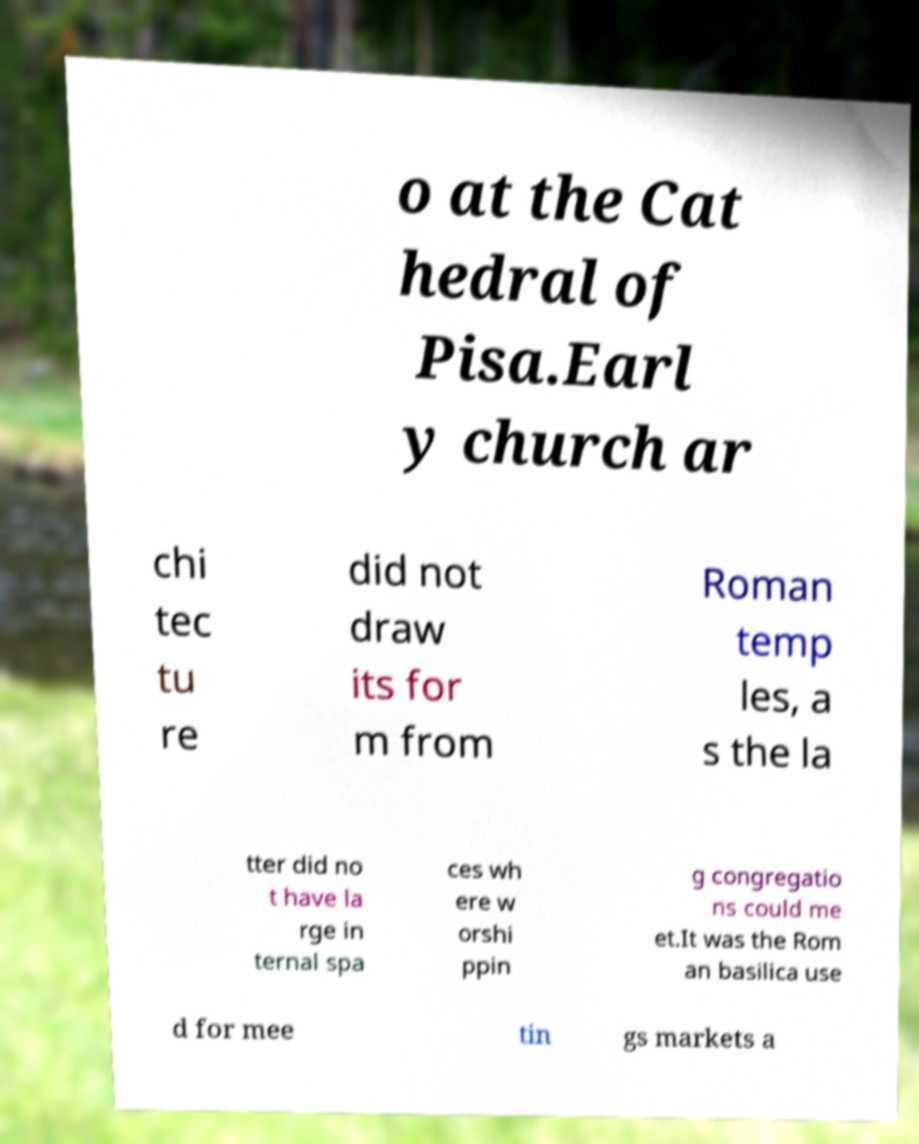For documentation purposes, I need the text within this image transcribed. Could you provide that? o at the Cat hedral of Pisa.Earl y church ar chi tec tu re did not draw its for m from Roman temp les, a s the la tter did no t have la rge in ternal spa ces wh ere w orshi ppin g congregatio ns could me et.It was the Rom an basilica use d for mee tin gs markets a 